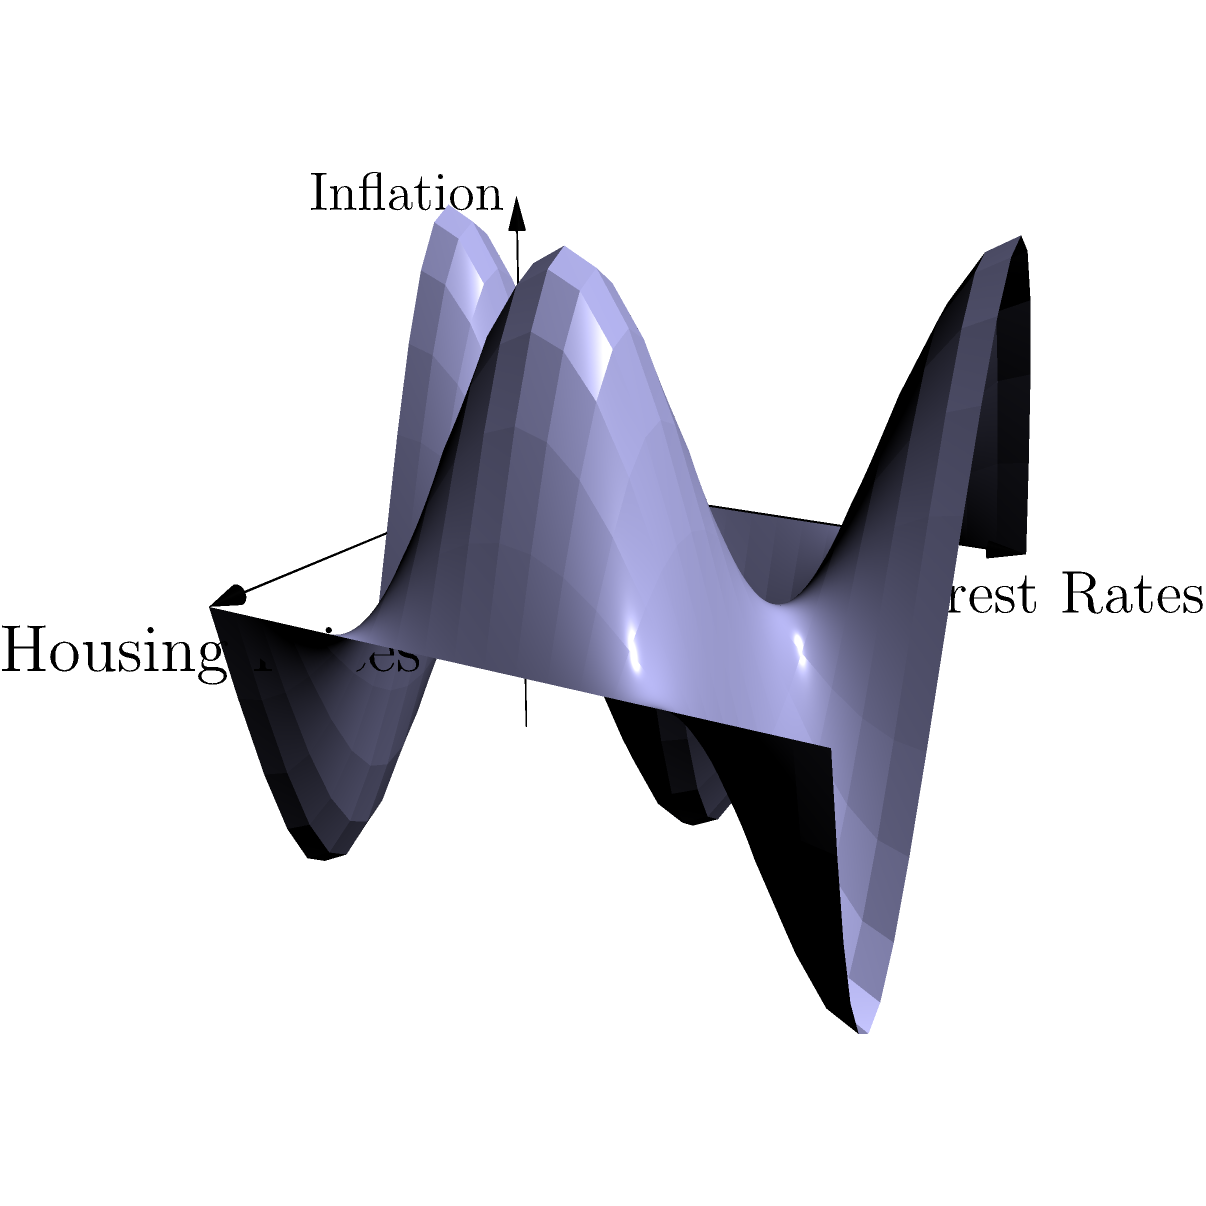Consider the surface $S$ shown in the figure, which represents the relationship between housing prices, interest rates, and inflation. If this surface is topologically equivalent to a torus with 2 holes, what is its Euler characteristic $\chi(S)$? To determine the Euler characteristic of the surface, we'll follow these steps:

1) Recall the formula for the Euler characteristic:
   $\chi = V - E + F$
   where $V$ is the number of vertices, $E$ is the number of edges, and $F$ is the number of faces.

2) For a surface topologically equivalent to a torus with $n$ holes (also known as a genus-$n$ surface), the Euler characteristic is given by:
   $\chi = 2 - 2g$
   where $g$ is the genus (number of holes).

3) In this case, we're told the surface is topologically equivalent to a torus with 2 holes, so $g = 2$.

4) Substituting into the formula:
   $\chi = 2 - 2(2) = 2 - 4 = -2$

Therefore, the Euler characteristic of the surface $S$ is $-2$.

This result is consistent with the complex topology of the surface shown in the figure, which represents the non-linear relationships between housing prices, interest rates, and inflation in a stochastic model.
Answer: $-2$ 